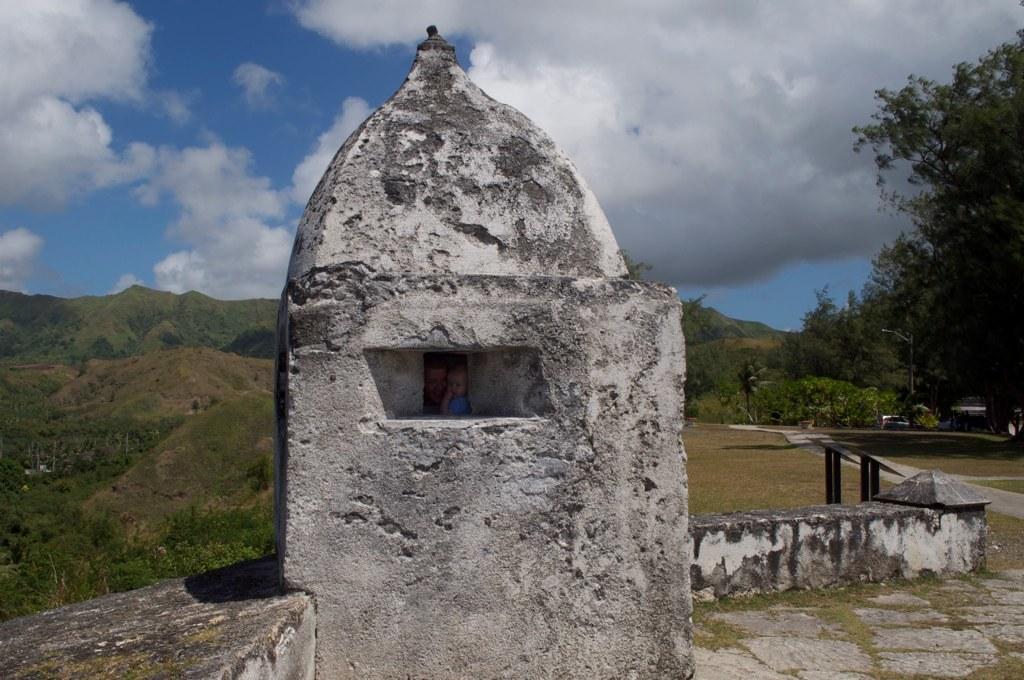In one or two sentences, can you explain what this image depicts? In this picture I can see a small tomb and I can see a human and a baby in the tomb from the outlet of it and I can see trees and hills and I can see grass on the ground and a blue cloudy sky. 